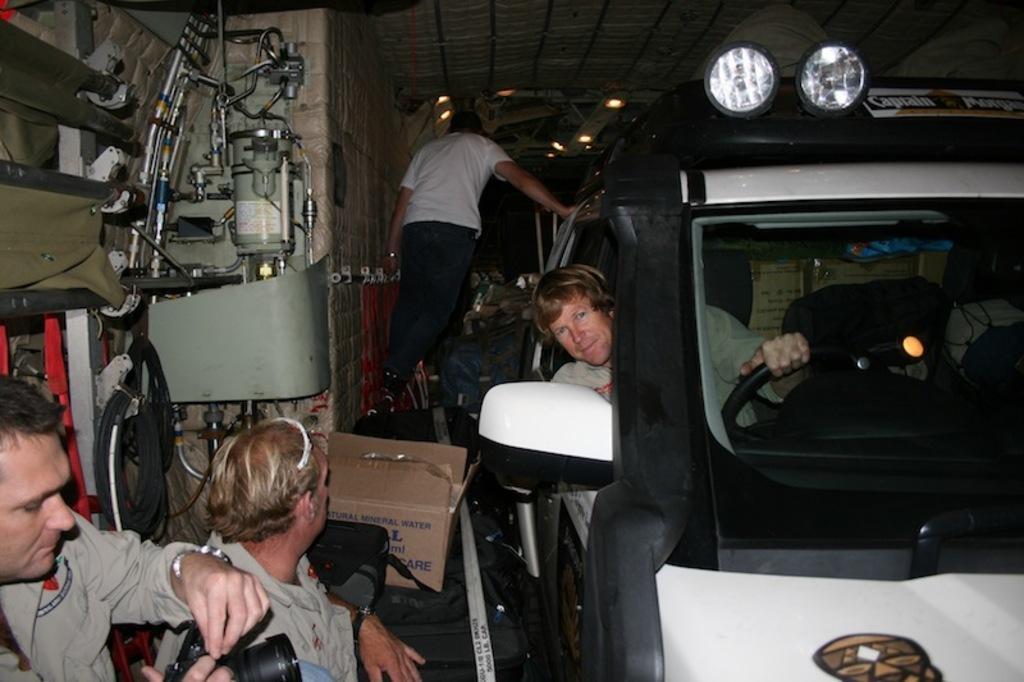How would you summarize this image in a sentence or two? In this image I see 4 persons, in which one of them is sitting in the car and there are lot of things over here. In the background I see the lights. 